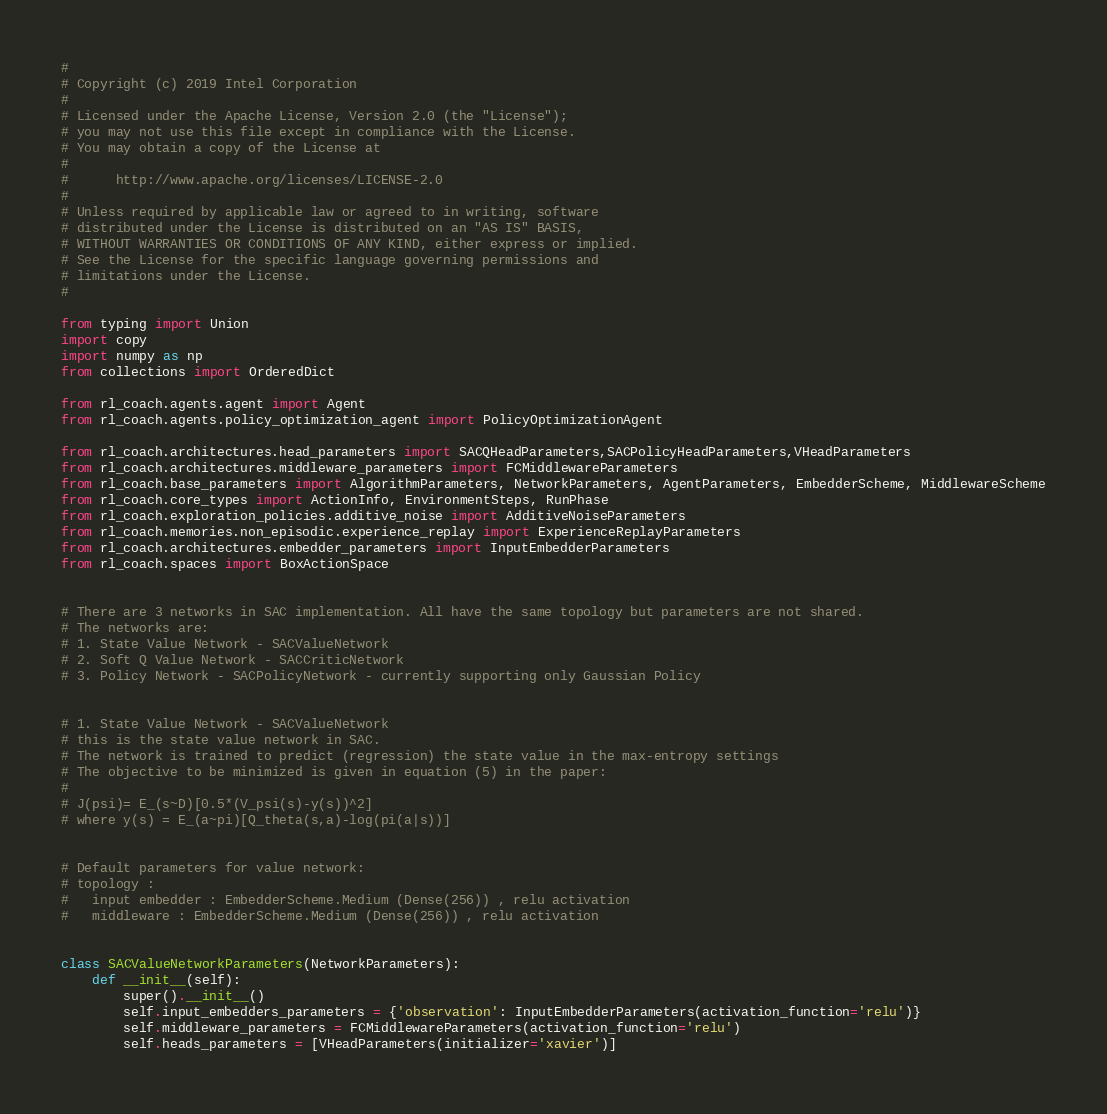<code> <loc_0><loc_0><loc_500><loc_500><_Python_>#
# Copyright (c) 2019 Intel Corporation
#
# Licensed under the Apache License, Version 2.0 (the "License");
# you may not use this file except in compliance with the License.
# You may obtain a copy of the License at
#
#      http://www.apache.org/licenses/LICENSE-2.0
#
# Unless required by applicable law or agreed to in writing, software
# distributed under the License is distributed on an "AS IS" BASIS,
# WITHOUT WARRANTIES OR CONDITIONS OF ANY KIND, either express or implied.
# See the License for the specific language governing permissions and
# limitations under the License.
#

from typing import Union
import copy
import numpy as np
from collections import OrderedDict

from rl_coach.agents.agent import Agent
from rl_coach.agents.policy_optimization_agent import PolicyOptimizationAgent

from rl_coach.architectures.head_parameters import SACQHeadParameters,SACPolicyHeadParameters,VHeadParameters
from rl_coach.architectures.middleware_parameters import FCMiddlewareParameters
from rl_coach.base_parameters import AlgorithmParameters, NetworkParameters, AgentParameters, EmbedderScheme, MiddlewareScheme
from rl_coach.core_types import ActionInfo, EnvironmentSteps, RunPhase
from rl_coach.exploration_policies.additive_noise import AdditiveNoiseParameters
from rl_coach.memories.non_episodic.experience_replay import ExperienceReplayParameters
from rl_coach.architectures.embedder_parameters import InputEmbedderParameters
from rl_coach.spaces import BoxActionSpace


# There are 3 networks in SAC implementation. All have the same topology but parameters are not shared.
# The networks are:
# 1. State Value Network - SACValueNetwork
# 2. Soft Q Value Network - SACCriticNetwork
# 3. Policy Network - SACPolicyNetwork - currently supporting only Gaussian Policy


# 1. State Value Network - SACValueNetwork
# this is the state value network in SAC.
# The network is trained to predict (regression) the state value in the max-entropy settings
# The objective to be minimized is given in equation (5) in the paper:
#
# J(psi)= E_(s~D)[0.5*(V_psi(s)-y(s))^2]
# where y(s) = E_(a~pi)[Q_theta(s,a)-log(pi(a|s))]


# Default parameters for value network:
# topology :
#   input embedder : EmbedderScheme.Medium (Dense(256)) , relu activation
#   middleware : EmbedderScheme.Medium (Dense(256)) , relu activation


class SACValueNetworkParameters(NetworkParameters):
    def __init__(self):
        super().__init__()
        self.input_embedders_parameters = {'observation': InputEmbedderParameters(activation_function='relu')}
        self.middleware_parameters = FCMiddlewareParameters(activation_function='relu')
        self.heads_parameters = [VHeadParameters(initializer='xavier')]</code> 